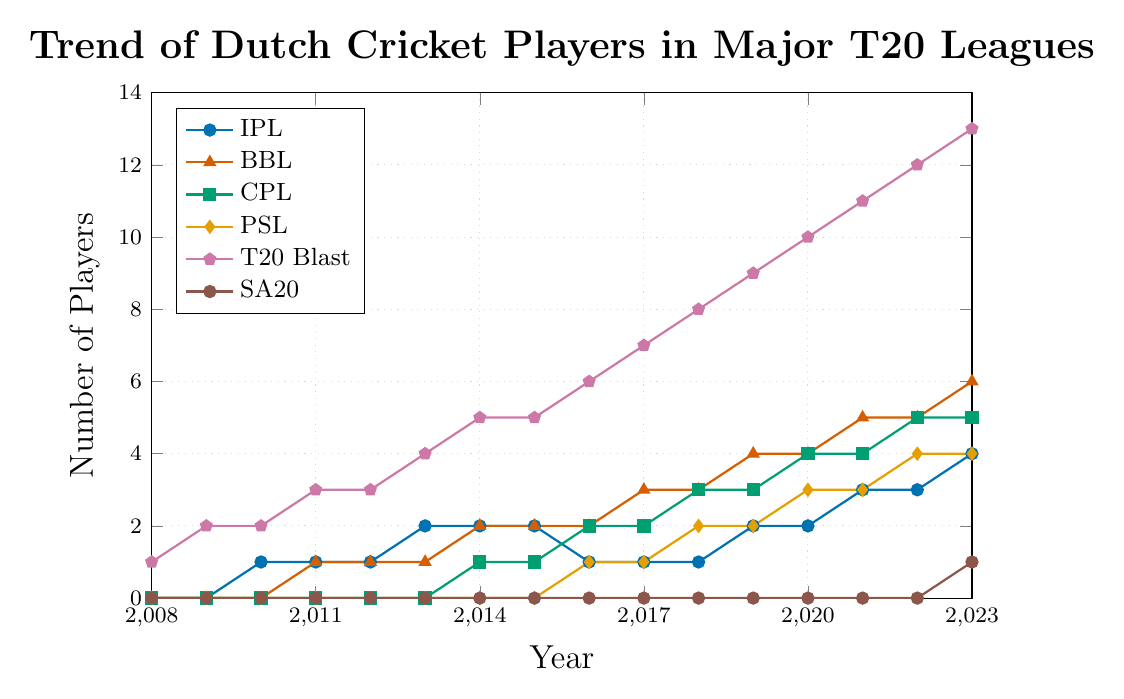What was the highest number of Dutch players participating in the T20 Blast over any year from 2008 to 2023? To find the highest number of Dutch players in the T20 Blast, check the data points for T20 Blast across all years. The highest value recorded is 13 in 2023.
Answer: 13 How many Dutch players participated in the IPL in 2021? Find the data point for the IPL in the year 2021, which shows 3 players.
Answer: 3 In which year did Dutch players first participate in the CPL, and how many were there? Look for the first non-zero data point for CPL, which appears in 2014 with 1 player.
Answer: 2014, 1 Compare the trends of Dutch players in the BBL and PSL from 2012 to 2023. Which league saw a greater increase in the number of players during this period? Count the number of players in 2012 and 2023 for both leagues: BBL (1 to 6), PSL (0 to 4). BBL increased by 5 players, while PSL increased by 4 players during this period.
Answer: BBL Which league had no Dutch players participating until after 2020? Look for the league with all zero data points until after 2020. The SA20 league has zero players from 2008 to 2022 and 1 player in 2023.
Answer: SA20 Determine the total number of Dutch players in major T20 leagues in 2019. Sum the data points for all leagues in 2019: IPL (2) + BBL (4) + CPL (3) + PSL (2) + T20 Blast (9) + SA20 (0) = 20 players.
Answer: 20 How did the participation in the IPL trend from 2016 to 2023? Observe the data points for the IPL from 2016 to 2023: 1 (2016), 1 (2017), 1 (2018), 2 (2019), 2 (2020), 3 (2021), 3 (2022), and 4 (2023). The trend shows a gradual increase.
Answer: Increasing Identify the year when Dutch players participated in all listed major T20 leagues for the first time. Check the data points for each league to find the first year when all are non-zero: IPL, BBL, CPL, PSL, T20 Blast, SA20. The year 2023 has non-zero values in all leagues.
Answer: 2023 What was the average number of Dutch players in the BBL from 2018 to 2023? Calculate the average for BBL data points from 2018 to 2023: (3 + 4 + 4 + 5 + 5 + 6) / 6 = 27 / 6 = 4.5.
Answer: 4.5 